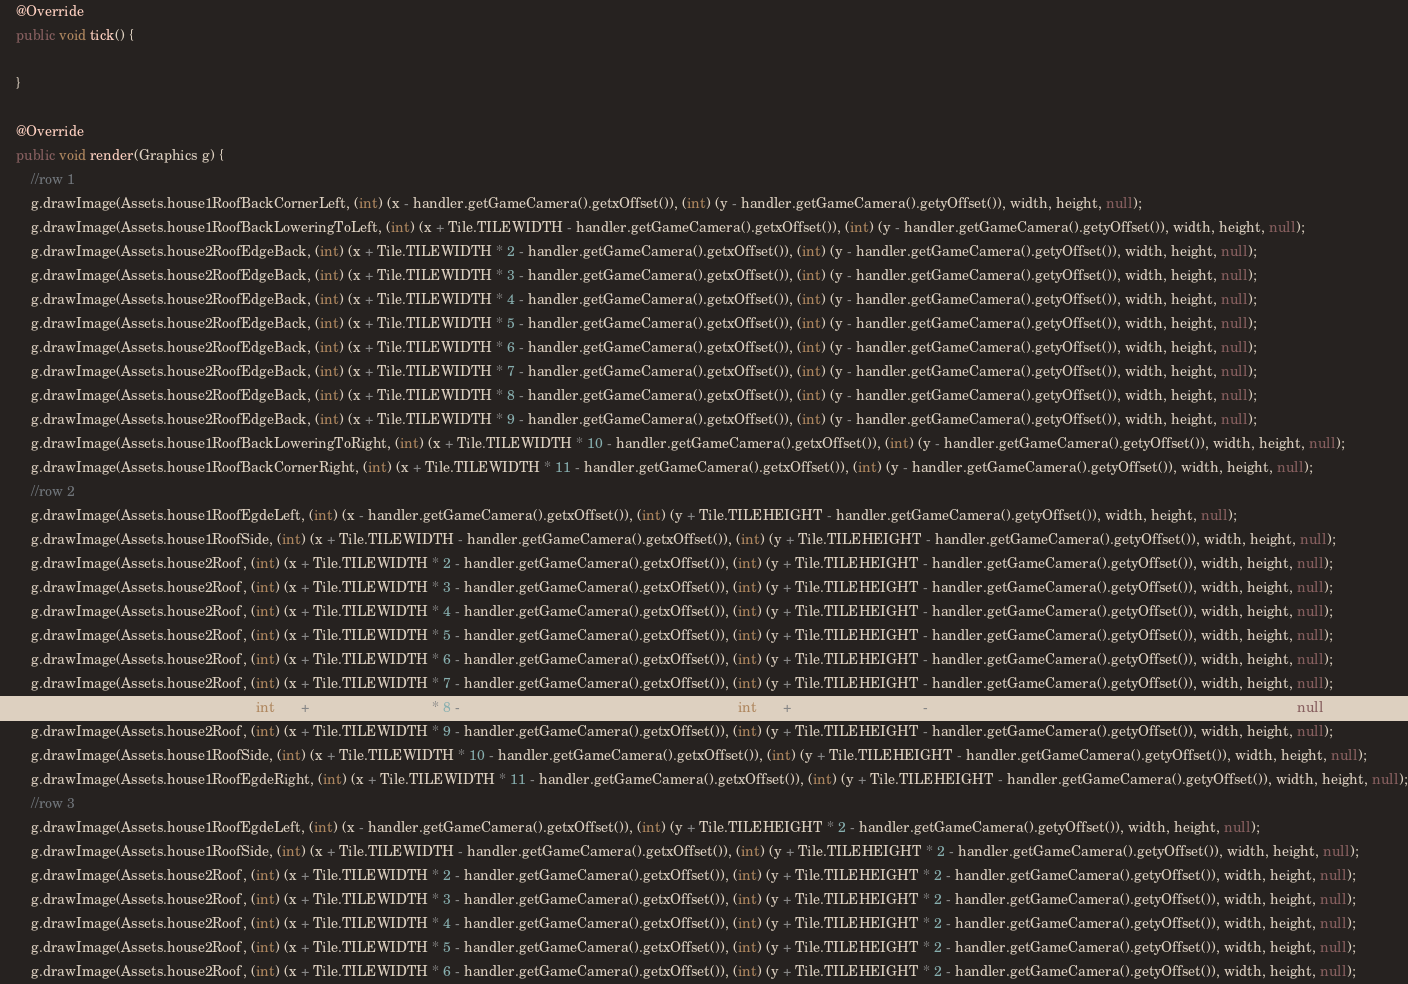Convert code to text. <code><loc_0><loc_0><loc_500><loc_500><_Java_>
    @Override
    public void tick() {

    }

    @Override
    public void render(Graphics g) {
        //row 1
        g.drawImage(Assets.house1RoofBackCornerLeft, (int) (x - handler.getGameCamera().getxOffset()), (int) (y - handler.getGameCamera().getyOffset()), width, height, null);
        g.drawImage(Assets.house1RoofBackLoweringToLeft, (int) (x + Tile.TILEWIDTH - handler.getGameCamera().getxOffset()), (int) (y - handler.getGameCamera().getyOffset()), width, height, null);
        g.drawImage(Assets.house2RoofEdgeBack, (int) (x + Tile.TILEWIDTH * 2 - handler.getGameCamera().getxOffset()), (int) (y - handler.getGameCamera().getyOffset()), width, height, null);
        g.drawImage(Assets.house2RoofEdgeBack, (int) (x + Tile.TILEWIDTH * 3 - handler.getGameCamera().getxOffset()), (int) (y - handler.getGameCamera().getyOffset()), width, height, null);
        g.drawImage(Assets.house2RoofEdgeBack, (int) (x + Tile.TILEWIDTH * 4 - handler.getGameCamera().getxOffset()), (int) (y - handler.getGameCamera().getyOffset()), width, height, null);
        g.drawImage(Assets.house2RoofEdgeBack, (int) (x + Tile.TILEWIDTH * 5 - handler.getGameCamera().getxOffset()), (int) (y - handler.getGameCamera().getyOffset()), width, height, null);
        g.drawImage(Assets.house2RoofEdgeBack, (int) (x + Tile.TILEWIDTH * 6 - handler.getGameCamera().getxOffset()), (int) (y - handler.getGameCamera().getyOffset()), width, height, null);
        g.drawImage(Assets.house2RoofEdgeBack, (int) (x + Tile.TILEWIDTH * 7 - handler.getGameCamera().getxOffset()), (int) (y - handler.getGameCamera().getyOffset()), width, height, null);
        g.drawImage(Assets.house2RoofEdgeBack, (int) (x + Tile.TILEWIDTH * 8 - handler.getGameCamera().getxOffset()), (int) (y - handler.getGameCamera().getyOffset()), width, height, null);
        g.drawImage(Assets.house2RoofEdgeBack, (int) (x + Tile.TILEWIDTH * 9 - handler.getGameCamera().getxOffset()), (int) (y - handler.getGameCamera().getyOffset()), width, height, null);
        g.drawImage(Assets.house1RoofBackLoweringToRight, (int) (x + Tile.TILEWIDTH * 10 - handler.getGameCamera().getxOffset()), (int) (y - handler.getGameCamera().getyOffset()), width, height, null);
        g.drawImage(Assets.house1RoofBackCornerRight, (int) (x + Tile.TILEWIDTH * 11 - handler.getGameCamera().getxOffset()), (int) (y - handler.getGameCamera().getyOffset()), width, height, null);
        //row 2
        g.drawImage(Assets.house1RoofEgdeLeft, (int) (x - handler.getGameCamera().getxOffset()), (int) (y + Tile.TILEHEIGHT - handler.getGameCamera().getyOffset()), width, height, null);
        g.drawImage(Assets.house1RoofSide, (int) (x + Tile.TILEWIDTH - handler.getGameCamera().getxOffset()), (int) (y + Tile.TILEHEIGHT - handler.getGameCamera().getyOffset()), width, height, null);
        g.drawImage(Assets.house2Roof, (int) (x + Tile.TILEWIDTH * 2 - handler.getGameCamera().getxOffset()), (int) (y + Tile.TILEHEIGHT - handler.getGameCamera().getyOffset()), width, height, null);
        g.drawImage(Assets.house2Roof, (int) (x + Tile.TILEWIDTH * 3 - handler.getGameCamera().getxOffset()), (int) (y + Tile.TILEHEIGHT - handler.getGameCamera().getyOffset()), width, height, null);
        g.drawImage(Assets.house2Roof, (int) (x + Tile.TILEWIDTH * 4 - handler.getGameCamera().getxOffset()), (int) (y + Tile.TILEHEIGHT - handler.getGameCamera().getyOffset()), width, height, null);
        g.drawImage(Assets.house2Roof, (int) (x + Tile.TILEWIDTH * 5 - handler.getGameCamera().getxOffset()), (int) (y + Tile.TILEHEIGHT - handler.getGameCamera().getyOffset()), width, height, null);
        g.drawImage(Assets.house2Roof, (int) (x + Tile.TILEWIDTH * 6 - handler.getGameCamera().getxOffset()), (int) (y + Tile.TILEHEIGHT - handler.getGameCamera().getyOffset()), width, height, null);
        g.drawImage(Assets.house2Roof, (int) (x + Tile.TILEWIDTH * 7 - handler.getGameCamera().getxOffset()), (int) (y + Tile.TILEHEIGHT - handler.getGameCamera().getyOffset()), width, height, null);
        g.drawImage(Assets.house2Roof, (int) (x + Tile.TILEWIDTH * 8 - handler.getGameCamera().getxOffset()), (int) (y + Tile.TILEHEIGHT - handler.getGameCamera().getyOffset()), width, height, null);
        g.drawImage(Assets.house2Roof, (int) (x + Tile.TILEWIDTH * 9 - handler.getGameCamera().getxOffset()), (int) (y + Tile.TILEHEIGHT - handler.getGameCamera().getyOffset()), width, height, null);
        g.drawImage(Assets.house1RoofSide, (int) (x + Tile.TILEWIDTH * 10 - handler.getGameCamera().getxOffset()), (int) (y + Tile.TILEHEIGHT - handler.getGameCamera().getyOffset()), width, height, null);
        g.drawImage(Assets.house1RoofEgdeRight, (int) (x + Tile.TILEWIDTH * 11 - handler.getGameCamera().getxOffset()), (int) (y + Tile.TILEHEIGHT - handler.getGameCamera().getyOffset()), width, height, null);
        //row 3 
        g.drawImage(Assets.house1RoofEgdeLeft, (int) (x - handler.getGameCamera().getxOffset()), (int) (y + Tile.TILEHEIGHT * 2 - handler.getGameCamera().getyOffset()), width, height, null);
        g.drawImage(Assets.house1RoofSide, (int) (x + Tile.TILEWIDTH - handler.getGameCamera().getxOffset()), (int) (y + Tile.TILEHEIGHT * 2 - handler.getGameCamera().getyOffset()), width, height, null);
        g.drawImage(Assets.house2Roof, (int) (x + Tile.TILEWIDTH * 2 - handler.getGameCamera().getxOffset()), (int) (y + Tile.TILEHEIGHT * 2 - handler.getGameCamera().getyOffset()), width, height, null);
        g.drawImage(Assets.house2Roof, (int) (x + Tile.TILEWIDTH * 3 - handler.getGameCamera().getxOffset()), (int) (y + Tile.TILEHEIGHT * 2 - handler.getGameCamera().getyOffset()), width, height, null);
        g.drawImage(Assets.house2Roof, (int) (x + Tile.TILEWIDTH * 4 - handler.getGameCamera().getxOffset()), (int) (y + Tile.TILEHEIGHT * 2 - handler.getGameCamera().getyOffset()), width, height, null);
        g.drawImage(Assets.house2Roof, (int) (x + Tile.TILEWIDTH * 5 - handler.getGameCamera().getxOffset()), (int) (y + Tile.TILEHEIGHT * 2 - handler.getGameCamera().getyOffset()), width, height, null);
        g.drawImage(Assets.house2Roof, (int) (x + Tile.TILEWIDTH * 6 - handler.getGameCamera().getxOffset()), (int) (y + Tile.TILEHEIGHT * 2 - handler.getGameCamera().getyOffset()), width, height, null);</code> 